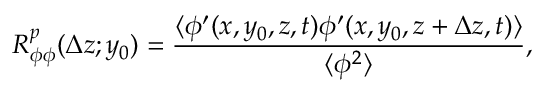Convert formula to latex. <formula><loc_0><loc_0><loc_500><loc_500>R _ { \phi \phi } ^ { p } ( \Delta z ; y _ { 0 } ) = \frac { \langle { \phi ^ { \prime } ( x , y _ { 0 } , z , t ) \phi ^ { \prime } ( x , y _ { 0 } , z + \Delta z , t ) } \rangle } { \langle { \phi ^ { 2 } } \rangle } ,</formula> 